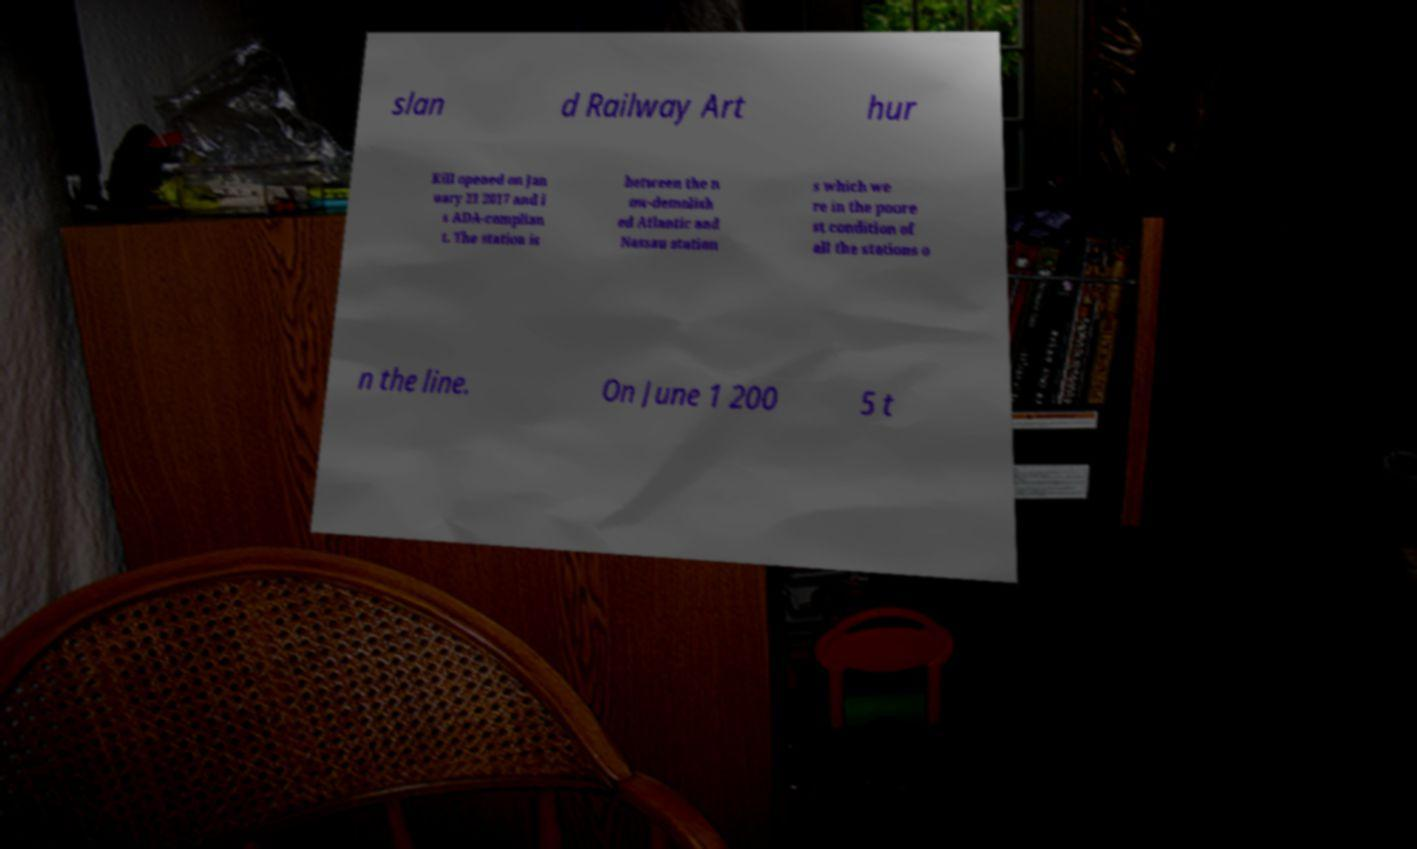For documentation purposes, I need the text within this image transcribed. Could you provide that? slan d Railway Art hur Kill opened on Jan uary 21 2017 and i s ADA-complian t. The station is between the n ow-demolish ed Atlantic and Nassau station s which we re in the poore st condition of all the stations o n the line. On June 1 200 5 t 